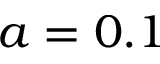Convert formula to latex. <formula><loc_0><loc_0><loc_500><loc_500>a = 0 . 1</formula> 